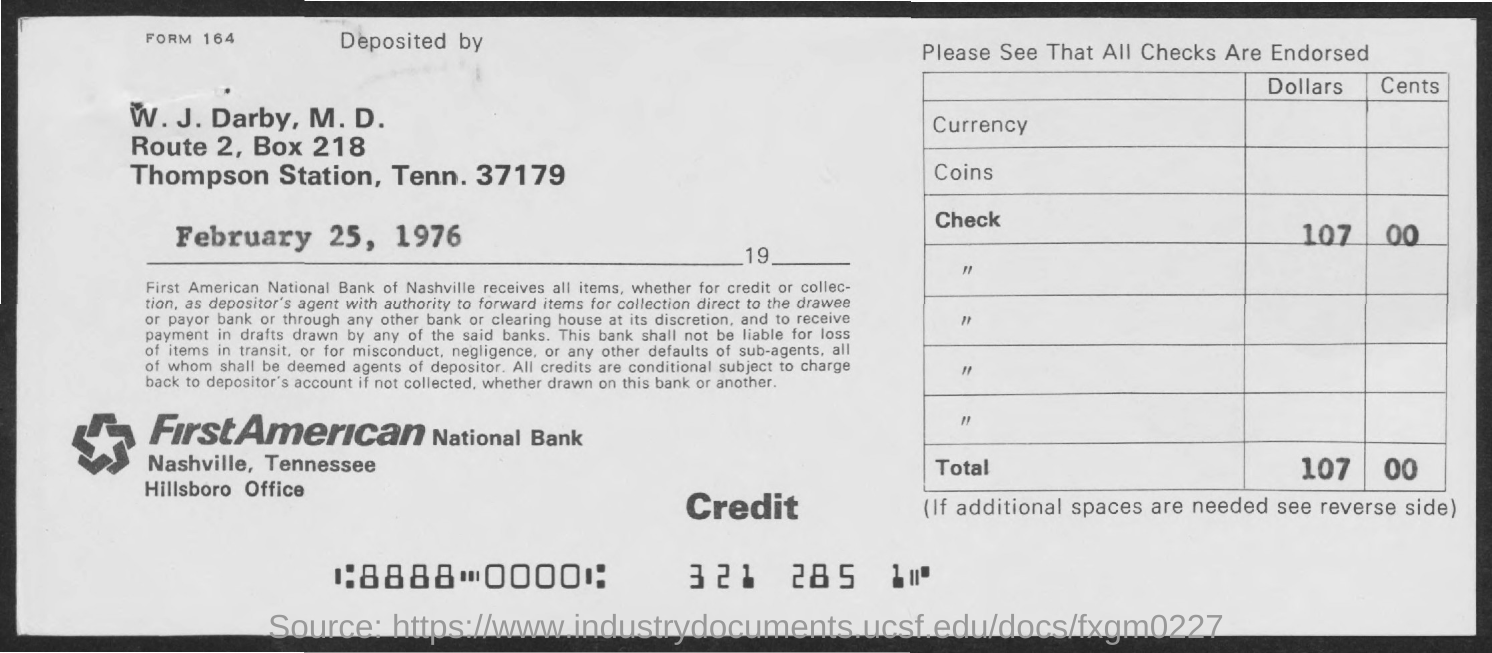What is the box no. mentioned ?
Provide a short and direct response. 218. What is the amount of dollars mentioned in the check ?
Offer a very short reply. 107. What is the station mentioned ?
Make the answer very short. Thompson station. What is the tenn. no. mentioned ?
Provide a succinct answer. 37179. What is the name of the bank mentioned ?
Keep it short and to the point. First American National Bank. What  is the name of the office mentioned?
Ensure brevity in your answer.  Hillsboro office. 